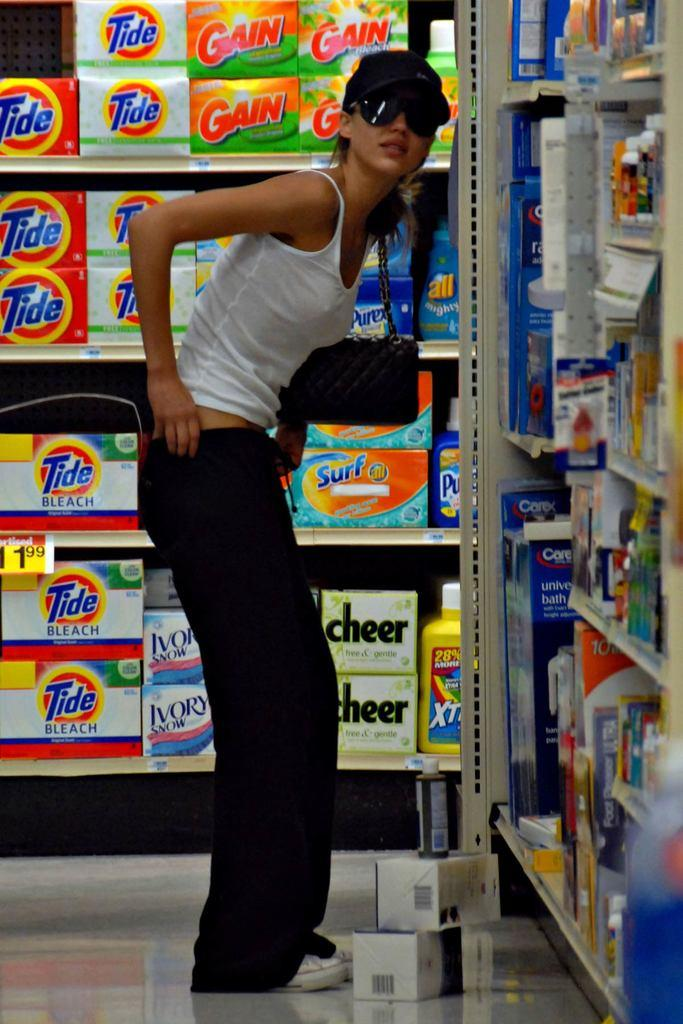<image>
Render a clear and concise summary of the photo. A woman standing near a product called Tide. 